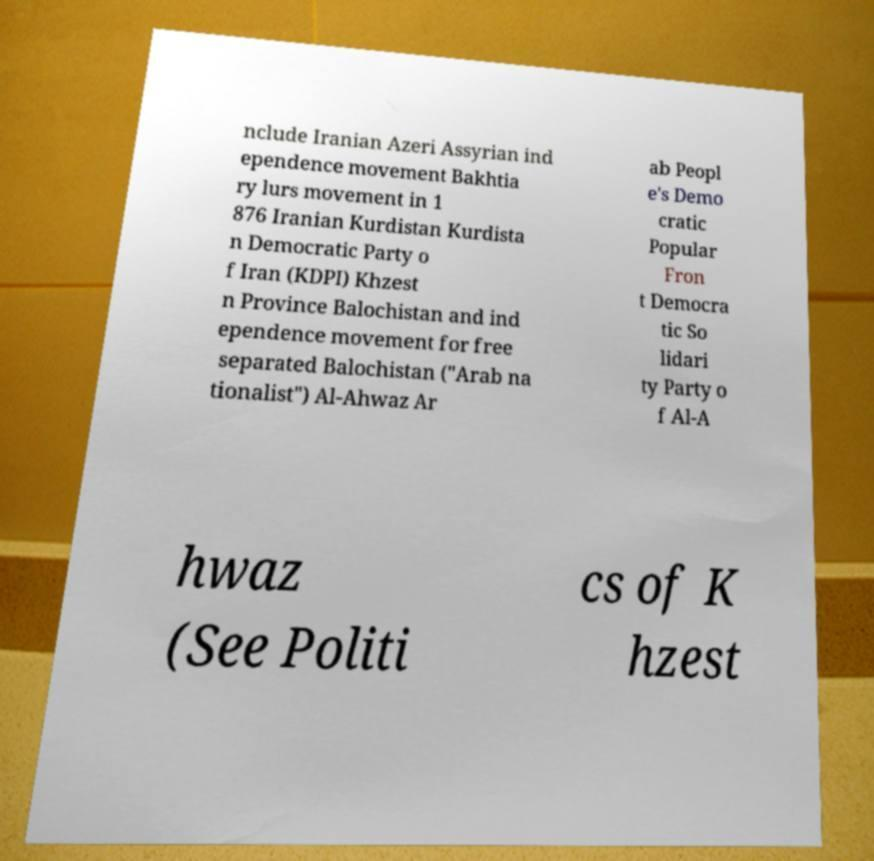Could you extract and type out the text from this image? nclude Iranian Azeri Assyrian ind ependence movement Bakhtia ry lurs movement in 1 876 Iranian Kurdistan Kurdista n Democratic Party o f Iran (KDPI) Khzest n Province Balochistan and ind ependence movement for free separated Balochistan ("Arab na tionalist") Al-Ahwaz Ar ab Peopl e's Demo cratic Popular Fron t Democra tic So lidari ty Party o f Al-A hwaz (See Politi cs of K hzest 